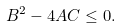<formula> <loc_0><loc_0><loc_500><loc_500>B ^ { 2 } - 4 A C \leq 0 .</formula> 